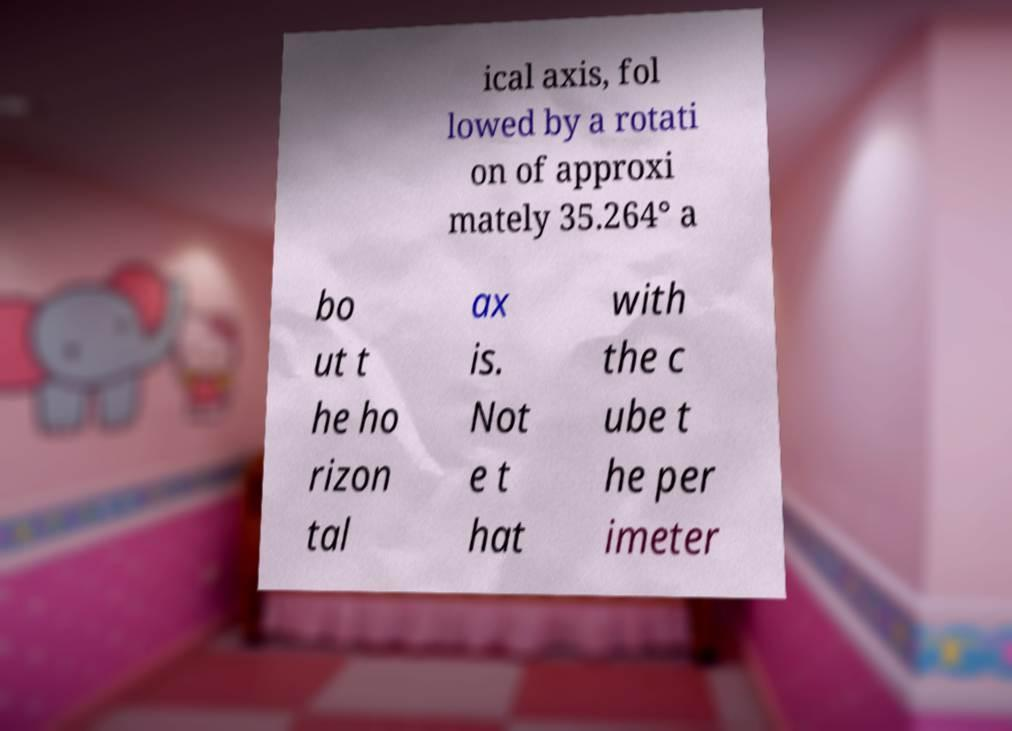Can you accurately transcribe the text from the provided image for me? ical axis, fol lowed by a rotati on of approxi mately 35.264° a bo ut t he ho rizon tal ax is. Not e t hat with the c ube t he per imeter 